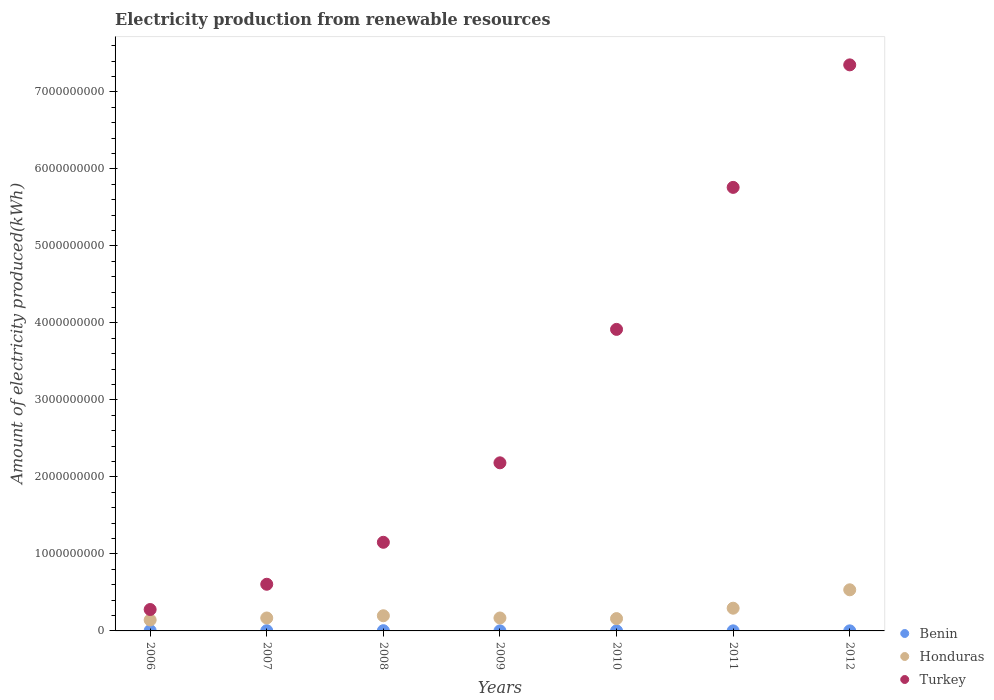How many different coloured dotlines are there?
Ensure brevity in your answer.  3. What is the amount of electricity produced in Benin in 2008?
Make the answer very short. 3.00e+06. Across all years, what is the maximum amount of electricity produced in Turkey?
Offer a very short reply. 7.35e+09. Across all years, what is the minimum amount of electricity produced in Turkey?
Make the answer very short. 2.78e+08. In which year was the amount of electricity produced in Benin minimum?
Provide a succinct answer. 2009. What is the total amount of electricity produced in Turkey in the graph?
Your answer should be very brief. 2.12e+1. What is the difference between the amount of electricity produced in Honduras in 2008 and that in 2010?
Your response must be concise. 3.70e+07. What is the difference between the amount of electricity produced in Honduras in 2010 and the amount of electricity produced in Benin in 2012?
Keep it short and to the point. 1.59e+08. What is the average amount of electricity produced in Honduras per year?
Give a very brief answer. 2.38e+08. In the year 2007, what is the difference between the amount of electricity produced in Turkey and amount of electricity produced in Honduras?
Offer a terse response. 4.38e+08. What is the ratio of the amount of electricity produced in Turkey in 2008 to that in 2010?
Offer a terse response. 0.29. What is the difference between the highest and the second highest amount of electricity produced in Honduras?
Your answer should be very brief. 2.39e+08. Is the sum of the amount of electricity produced in Turkey in 2007 and 2012 greater than the maximum amount of electricity produced in Honduras across all years?
Your answer should be compact. Yes. Does the amount of electricity produced in Turkey monotonically increase over the years?
Your answer should be compact. Yes. Is the amount of electricity produced in Turkey strictly less than the amount of electricity produced in Benin over the years?
Give a very brief answer. No. How many dotlines are there?
Keep it short and to the point. 3. What is the difference between two consecutive major ticks on the Y-axis?
Your answer should be very brief. 1.00e+09. Are the values on the major ticks of Y-axis written in scientific E-notation?
Your response must be concise. No. Does the graph contain any zero values?
Provide a short and direct response. No. Where does the legend appear in the graph?
Your answer should be compact. Bottom right. How are the legend labels stacked?
Keep it short and to the point. Vertical. What is the title of the graph?
Give a very brief answer. Electricity production from renewable resources. What is the label or title of the Y-axis?
Your answer should be compact. Amount of electricity produced(kWh). What is the Amount of electricity produced(kWh) of Honduras in 2006?
Your answer should be compact. 1.42e+08. What is the Amount of electricity produced(kWh) in Turkey in 2006?
Provide a short and direct response. 2.78e+08. What is the Amount of electricity produced(kWh) of Benin in 2007?
Give a very brief answer. 3.00e+06. What is the Amount of electricity produced(kWh) in Honduras in 2007?
Your answer should be compact. 1.68e+08. What is the Amount of electricity produced(kWh) in Turkey in 2007?
Ensure brevity in your answer.  6.06e+08. What is the Amount of electricity produced(kWh) of Honduras in 2008?
Offer a terse response. 1.97e+08. What is the Amount of electricity produced(kWh) of Turkey in 2008?
Provide a short and direct response. 1.15e+09. What is the Amount of electricity produced(kWh) in Honduras in 2009?
Ensure brevity in your answer.  1.68e+08. What is the Amount of electricity produced(kWh) in Turkey in 2009?
Keep it short and to the point. 2.18e+09. What is the Amount of electricity produced(kWh) in Benin in 2010?
Give a very brief answer. 1.00e+06. What is the Amount of electricity produced(kWh) of Honduras in 2010?
Your response must be concise. 1.60e+08. What is the Amount of electricity produced(kWh) in Turkey in 2010?
Provide a succinct answer. 3.92e+09. What is the Amount of electricity produced(kWh) in Honduras in 2011?
Offer a very short reply. 2.95e+08. What is the Amount of electricity produced(kWh) of Turkey in 2011?
Offer a very short reply. 5.76e+09. What is the Amount of electricity produced(kWh) in Honduras in 2012?
Provide a succinct answer. 5.34e+08. What is the Amount of electricity produced(kWh) in Turkey in 2012?
Your answer should be compact. 7.35e+09. Across all years, what is the maximum Amount of electricity produced(kWh) of Benin?
Offer a terse response. 4.00e+06. Across all years, what is the maximum Amount of electricity produced(kWh) of Honduras?
Ensure brevity in your answer.  5.34e+08. Across all years, what is the maximum Amount of electricity produced(kWh) in Turkey?
Give a very brief answer. 7.35e+09. Across all years, what is the minimum Amount of electricity produced(kWh) in Benin?
Make the answer very short. 1.00e+06. Across all years, what is the minimum Amount of electricity produced(kWh) in Honduras?
Provide a succinct answer. 1.42e+08. Across all years, what is the minimum Amount of electricity produced(kWh) of Turkey?
Ensure brevity in your answer.  2.78e+08. What is the total Amount of electricity produced(kWh) of Benin in the graph?
Your answer should be very brief. 1.40e+07. What is the total Amount of electricity produced(kWh) of Honduras in the graph?
Give a very brief answer. 1.66e+09. What is the total Amount of electricity produced(kWh) in Turkey in the graph?
Your answer should be compact. 2.12e+1. What is the difference between the Amount of electricity produced(kWh) in Benin in 2006 and that in 2007?
Make the answer very short. 1.00e+06. What is the difference between the Amount of electricity produced(kWh) in Honduras in 2006 and that in 2007?
Offer a very short reply. -2.60e+07. What is the difference between the Amount of electricity produced(kWh) of Turkey in 2006 and that in 2007?
Your response must be concise. -3.28e+08. What is the difference between the Amount of electricity produced(kWh) in Benin in 2006 and that in 2008?
Make the answer very short. 1.00e+06. What is the difference between the Amount of electricity produced(kWh) of Honduras in 2006 and that in 2008?
Offer a terse response. -5.50e+07. What is the difference between the Amount of electricity produced(kWh) of Turkey in 2006 and that in 2008?
Your answer should be very brief. -8.73e+08. What is the difference between the Amount of electricity produced(kWh) of Benin in 2006 and that in 2009?
Ensure brevity in your answer.  3.00e+06. What is the difference between the Amount of electricity produced(kWh) of Honduras in 2006 and that in 2009?
Offer a terse response. -2.60e+07. What is the difference between the Amount of electricity produced(kWh) of Turkey in 2006 and that in 2009?
Your answer should be very brief. -1.90e+09. What is the difference between the Amount of electricity produced(kWh) in Honduras in 2006 and that in 2010?
Your answer should be very brief. -1.80e+07. What is the difference between the Amount of electricity produced(kWh) in Turkey in 2006 and that in 2010?
Your answer should be compact. -3.64e+09. What is the difference between the Amount of electricity produced(kWh) in Benin in 2006 and that in 2011?
Provide a short and direct response. 3.00e+06. What is the difference between the Amount of electricity produced(kWh) in Honduras in 2006 and that in 2011?
Offer a terse response. -1.53e+08. What is the difference between the Amount of electricity produced(kWh) in Turkey in 2006 and that in 2011?
Offer a terse response. -5.48e+09. What is the difference between the Amount of electricity produced(kWh) in Honduras in 2006 and that in 2012?
Your answer should be compact. -3.92e+08. What is the difference between the Amount of electricity produced(kWh) in Turkey in 2006 and that in 2012?
Provide a succinct answer. -7.07e+09. What is the difference between the Amount of electricity produced(kWh) of Benin in 2007 and that in 2008?
Provide a short and direct response. 0. What is the difference between the Amount of electricity produced(kWh) of Honduras in 2007 and that in 2008?
Offer a terse response. -2.90e+07. What is the difference between the Amount of electricity produced(kWh) in Turkey in 2007 and that in 2008?
Keep it short and to the point. -5.45e+08. What is the difference between the Amount of electricity produced(kWh) of Honduras in 2007 and that in 2009?
Offer a very short reply. 0. What is the difference between the Amount of electricity produced(kWh) of Turkey in 2007 and that in 2009?
Provide a short and direct response. -1.58e+09. What is the difference between the Amount of electricity produced(kWh) in Benin in 2007 and that in 2010?
Make the answer very short. 2.00e+06. What is the difference between the Amount of electricity produced(kWh) in Turkey in 2007 and that in 2010?
Offer a very short reply. -3.31e+09. What is the difference between the Amount of electricity produced(kWh) of Honduras in 2007 and that in 2011?
Offer a very short reply. -1.27e+08. What is the difference between the Amount of electricity produced(kWh) of Turkey in 2007 and that in 2011?
Keep it short and to the point. -5.15e+09. What is the difference between the Amount of electricity produced(kWh) of Honduras in 2007 and that in 2012?
Your answer should be compact. -3.66e+08. What is the difference between the Amount of electricity produced(kWh) in Turkey in 2007 and that in 2012?
Offer a terse response. -6.74e+09. What is the difference between the Amount of electricity produced(kWh) of Honduras in 2008 and that in 2009?
Keep it short and to the point. 2.90e+07. What is the difference between the Amount of electricity produced(kWh) in Turkey in 2008 and that in 2009?
Offer a very short reply. -1.03e+09. What is the difference between the Amount of electricity produced(kWh) in Honduras in 2008 and that in 2010?
Keep it short and to the point. 3.70e+07. What is the difference between the Amount of electricity produced(kWh) in Turkey in 2008 and that in 2010?
Your answer should be compact. -2.76e+09. What is the difference between the Amount of electricity produced(kWh) of Benin in 2008 and that in 2011?
Keep it short and to the point. 2.00e+06. What is the difference between the Amount of electricity produced(kWh) in Honduras in 2008 and that in 2011?
Your response must be concise. -9.80e+07. What is the difference between the Amount of electricity produced(kWh) in Turkey in 2008 and that in 2011?
Your answer should be very brief. -4.61e+09. What is the difference between the Amount of electricity produced(kWh) in Honduras in 2008 and that in 2012?
Ensure brevity in your answer.  -3.37e+08. What is the difference between the Amount of electricity produced(kWh) in Turkey in 2008 and that in 2012?
Offer a very short reply. -6.20e+09. What is the difference between the Amount of electricity produced(kWh) of Turkey in 2009 and that in 2010?
Provide a short and direct response. -1.73e+09. What is the difference between the Amount of electricity produced(kWh) of Honduras in 2009 and that in 2011?
Offer a terse response. -1.27e+08. What is the difference between the Amount of electricity produced(kWh) of Turkey in 2009 and that in 2011?
Ensure brevity in your answer.  -3.58e+09. What is the difference between the Amount of electricity produced(kWh) in Honduras in 2009 and that in 2012?
Your answer should be very brief. -3.66e+08. What is the difference between the Amount of electricity produced(kWh) of Turkey in 2009 and that in 2012?
Offer a very short reply. -5.17e+09. What is the difference between the Amount of electricity produced(kWh) in Honduras in 2010 and that in 2011?
Your answer should be compact. -1.35e+08. What is the difference between the Amount of electricity produced(kWh) in Turkey in 2010 and that in 2011?
Your answer should be compact. -1.84e+09. What is the difference between the Amount of electricity produced(kWh) in Benin in 2010 and that in 2012?
Offer a terse response. 0. What is the difference between the Amount of electricity produced(kWh) in Honduras in 2010 and that in 2012?
Your answer should be very brief. -3.74e+08. What is the difference between the Amount of electricity produced(kWh) in Turkey in 2010 and that in 2012?
Your answer should be very brief. -3.44e+09. What is the difference between the Amount of electricity produced(kWh) in Benin in 2011 and that in 2012?
Give a very brief answer. 0. What is the difference between the Amount of electricity produced(kWh) in Honduras in 2011 and that in 2012?
Your answer should be compact. -2.39e+08. What is the difference between the Amount of electricity produced(kWh) of Turkey in 2011 and that in 2012?
Offer a very short reply. -1.59e+09. What is the difference between the Amount of electricity produced(kWh) of Benin in 2006 and the Amount of electricity produced(kWh) of Honduras in 2007?
Keep it short and to the point. -1.64e+08. What is the difference between the Amount of electricity produced(kWh) in Benin in 2006 and the Amount of electricity produced(kWh) in Turkey in 2007?
Your answer should be compact. -6.02e+08. What is the difference between the Amount of electricity produced(kWh) of Honduras in 2006 and the Amount of electricity produced(kWh) of Turkey in 2007?
Make the answer very short. -4.64e+08. What is the difference between the Amount of electricity produced(kWh) in Benin in 2006 and the Amount of electricity produced(kWh) in Honduras in 2008?
Make the answer very short. -1.93e+08. What is the difference between the Amount of electricity produced(kWh) in Benin in 2006 and the Amount of electricity produced(kWh) in Turkey in 2008?
Offer a terse response. -1.15e+09. What is the difference between the Amount of electricity produced(kWh) of Honduras in 2006 and the Amount of electricity produced(kWh) of Turkey in 2008?
Your answer should be very brief. -1.01e+09. What is the difference between the Amount of electricity produced(kWh) of Benin in 2006 and the Amount of electricity produced(kWh) of Honduras in 2009?
Your answer should be compact. -1.64e+08. What is the difference between the Amount of electricity produced(kWh) of Benin in 2006 and the Amount of electricity produced(kWh) of Turkey in 2009?
Give a very brief answer. -2.18e+09. What is the difference between the Amount of electricity produced(kWh) of Honduras in 2006 and the Amount of electricity produced(kWh) of Turkey in 2009?
Give a very brief answer. -2.04e+09. What is the difference between the Amount of electricity produced(kWh) of Benin in 2006 and the Amount of electricity produced(kWh) of Honduras in 2010?
Provide a succinct answer. -1.56e+08. What is the difference between the Amount of electricity produced(kWh) of Benin in 2006 and the Amount of electricity produced(kWh) of Turkey in 2010?
Make the answer very short. -3.91e+09. What is the difference between the Amount of electricity produced(kWh) of Honduras in 2006 and the Amount of electricity produced(kWh) of Turkey in 2010?
Provide a short and direct response. -3.77e+09. What is the difference between the Amount of electricity produced(kWh) in Benin in 2006 and the Amount of electricity produced(kWh) in Honduras in 2011?
Your response must be concise. -2.91e+08. What is the difference between the Amount of electricity produced(kWh) in Benin in 2006 and the Amount of electricity produced(kWh) in Turkey in 2011?
Your answer should be very brief. -5.76e+09. What is the difference between the Amount of electricity produced(kWh) of Honduras in 2006 and the Amount of electricity produced(kWh) of Turkey in 2011?
Your answer should be compact. -5.62e+09. What is the difference between the Amount of electricity produced(kWh) of Benin in 2006 and the Amount of electricity produced(kWh) of Honduras in 2012?
Give a very brief answer. -5.30e+08. What is the difference between the Amount of electricity produced(kWh) of Benin in 2006 and the Amount of electricity produced(kWh) of Turkey in 2012?
Offer a very short reply. -7.35e+09. What is the difference between the Amount of electricity produced(kWh) of Honduras in 2006 and the Amount of electricity produced(kWh) of Turkey in 2012?
Provide a succinct answer. -7.21e+09. What is the difference between the Amount of electricity produced(kWh) in Benin in 2007 and the Amount of electricity produced(kWh) in Honduras in 2008?
Provide a short and direct response. -1.94e+08. What is the difference between the Amount of electricity produced(kWh) of Benin in 2007 and the Amount of electricity produced(kWh) of Turkey in 2008?
Offer a very short reply. -1.15e+09. What is the difference between the Amount of electricity produced(kWh) of Honduras in 2007 and the Amount of electricity produced(kWh) of Turkey in 2008?
Your response must be concise. -9.83e+08. What is the difference between the Amount of electricity produced(kWh) of Benin in 2007 and the Amount of electricity produced(kWh) of Honduras in 2009?
Make the answer very short. -1.65e+08. What is the difference between the Amount of electricity produced(kWh) in Benin in 2007 and the Amount of electricity produced(kWh) in Turkey in 2009?
Give a very brief answer. -2.18e+09. What is the difference between the Amount of electricity produced(kWh) of Honduras in 2007 and the Amount of electricity produced(kWh) of Turkey in 2009?
Your answer should be compact. -2.02e+09. What is the difference between the Amount of electricity produced(kWh) of Benin in 2007 and the Amount of electricity produced(kWh) of Honduras in 2010?
Give a very brief answer. -1.57e+08. What is the difference between the Amount of electricity produced(kWh) in Benin in 2007 and the Amount of electricity produced(kWh) in Turkey in 2010?
Keep it short and to the point. -3.91e+09. What is the difference between the Amount of electricity produced(kWh) in Honduras in 2007 and the Amount of electricity produced(kWh) in Turkey in 2010?
Your answer should be very brief. -3.75e+09. What is the difference between the Amount of electricity produced(kWh) of Benin in 2007 and the Amount of electricity produced(kWh) of Honduras in 2011?
Ensure brevity in your answer.  -2.92e+08. What is the difference between the Amount of electricity produced(kWh) in Benin in 2007 and the Amount of electricity produced(kWh) in Turkey in 2011?
Provide a succinct answer. -5.76e+09. What is the difference between the Amount of electricity produced(kWh) of Honduras in 2007 and the Amount of electricity produced(kWh) of Turkey in 2011?
Offer a very short reply. -5.59e+09. What is the difference between the Amount of electricity produced(kWh) in Benin in 2007 and the Amount of electricity produced(kWh) in Honduras in 2012?
Offer a terse response. -5.31e+08. What is the difference between the Amount of electricity produced(kWh) of Benin in 2007 and the Amount of electricity produced(kWh) of Turkey in 2012?
Give a very brief answer. -7.35e+09. What is the difference between the Amount of electricity produced(kWh) in Honduras in 2007 and the Amount of electricity produced(kWh) in Turkey in 2012?
Give a very brief answer. -7.18e+09. What is the difference between the Amount of electricity produced(kWh) of Benin in 2008 and the Amount of electricity produced(kWh) of Honduras in 2009?
Your answer should be compact. -1.65e+08. What is the difference between the Amount of electricity produced(kWh) in Benin in 2008 and the Amount of electricity produced(kWh) in Turkey in 2009?
Keep it short and to the point. -2.18e+09. What is the difference between the Amount of electricity produced(kWh) of Honduras in 2008 and the Amount of electricity produced(kWh) of Turkey in 2009?
Ensure brevity in your answer.  -1.99e+09. What is the difference between the Amount of electricity produced(kWh) in Benin in 2008 and the Amount of electricity produced(kWh) in Honduras in 2010?
Give a very brief answer. -1.57e+08. What is the difference between the Amount of electricity produced(kWh) of Benin in 2008 and the Amount of electricity produced(kWh) of Turkey in 2010?
Provide a short and direct response. -3.91e+09. What is the difference between the Amount of electricity produced(kWh) in Honduras in 2008 and the Amount of electricity produced(kWh) in Turkey in 2010?
Give a very brief answer. -3.72e+09. What is the difference between the Amount of electricity produced(kWh) of Benin in 2008 and the Amount of electricity produced(kWh) of Honduras in 2011?
Make the answer very short. -2.92e+08. What is the difference between the Amount of electricity produced(kWh) of Benin in 2008 and the Amount of electricity produced(kWh) of Turkey in 2011?
Offer a very short reply. -5.76e+09. What is the difference between the Amount of electricity produced(kWh) of Honduras in 2008 and the Amount of electricity produced(kWh) of Turkey in 2011?
Offer a terse response. -5.56e+09. What is the difference between the Amount of electricity produced(kWh) of Benin in 2008 and the Amount of electricity produced(kWh) of Honduras in 2012?
Offer a very short reply. -5.31e+08. What is the difference between the Amount of electricity produced(kWh) in Benin in 2008 and the Amount of electricity produced(kWh) in Turkey in 2012?
Provide a succinct answer. -7.35e+09. What is the difference between the Amount of electricity produced(kWh) in Honduras in 2008 and the Amount of electricity produced(kWh) in Turkey in 2012?
Provide a succinct answer. -7.15e+09. What is the difference between the Amount of electricity produced(kWh) of Benin in 2009 and the Amount of electricity produced(kWh) of Honduras in 2010?
Provide a short and direct response. -1.59e+08. What is the difference between the Amount of electricity produced(kWh) of Benin in 2009 and the Amount of electricity produced(kWh) of Turkey in 2010?
Make the answer very short. -3.92e+09. What is the difference between the Amount of electricity produced(kWh) in Honduras in 2009 and the Amount of electricity produced(kWh) in Turkey in 2010?
Provide a succinct answer. -3.75e+09. What is the difference between the Amount of electricity produced(kWh) in Benin in 2009 and the Amount of electricity produced(kWh) in Honduras in 2011?
Your answer should be very brief. -2.94e+08. What is the difference between the Amount of electricity produced(kWh) of Benin in 2009 and the Amount of electricity produced(kWh) of Turkey in 2011?
Offer a very short reply. -5.76e+09. What is the difference between the Amount of electricity produced(kWh) of Honduras in 2009 and the Amount of electricity produced(kWh) of Turkey in 2011?
Make the answer very short. -5.59e+09. What is the difference between the Amount of electricity produced(kWh) in Benin in 2009 and the Amount of electricity produced(kWh) in Honduras in 2012?
Ensure brevity in your answer.  -5.33e+08. What is the difference between the Amount of electricity produced(kWh) of Benin in 2009 and the Amount of electricity produced(kWh) of Turkey in 2012?
Make the answer very short. -7.35e+09. What is the difference between the Amount of electricity produced(kWh) in Honduras in 2009 and the Amount of electricity produced(kWh) in Turkey in 2012?
Provide a succinct answer. -7.18e+09. What is the difference between the Amount of electricity produced(kWh) in Benin in 2010 and the Amount of electricity produced(kWh) in Honduras in 2011?
Give a very brief answer. -2.94e+08. What is the difference between the Amount of electricity produced(kWh) of Benin in 2010 and the Amount of electricity produced(kWh) of Turkey in 2011?
Keep it short and to the point. -5.76e+09. What is the difference between the Amount of electricity produced(kWh) in Honduras in 2010 and the Amount of electricity produced(kWh) in Turkey in 2011?
Provide a succinct answer. -5.60e+09. What is the difference between the Amount of electricity produced(kWh) of Benin in 2010 and the Amount of electricity produced(kWh) of Honduras in 2012?
Your answer should be compact. -5.33e+08. What is the difference between the Amount of electricity produced(kWh) in Benin in 2010 and the Amount of electricity produced(kWh) in Turkey in 2012?
Keep it short and to the point. -7.35e+09. What is the difference between the Amount of electricity produced(kWh) of Honduras in 2010 and the Amount of electricity produced(kWh) of Turkey in 2012?
Make the answer very short. -7.19e+09. What is the difference between the Amount of electricity produced(kWh) in Benin in 2011 and the Amount of electricity produced(kWh) in Honduras in 2012?
Keep it short and to the point. -5.33e+08. What is the difference between the Amount of electricity produced(kWh) of Benin in 2011 and the Amount of electricity produced(kWh) of Turkey in 2012?
Keep it short and to the point. -7.35e+09. What is the difference between the Amount of electricity produced(kWh) in Honduras in 2011 and the Amount of electricity produced(kWh) in Turkey in 2012?
Ensure brevity in your answer.  -7.06e+09. What is the average Amount of electricity produced(kWh) in Benin per year?
Your response must be concise. 2.00e+06. What is the average Amount of electricity produced(kWh) of Honduras per year?
Make the answer very short. 2.38e+08. What is the average Amount of electricity produced(kWh) of Turkey per year?
Give a very brief answer. 3.04e+09. In the year 2006, what is the difference between the Amount of electricity produced(kWh) of Benin and Amount of electricity produced(kWh) of Honduras?
Provide a short and direct response. -1.38e+08. In the year 2006, what is the difference between the Amount of electricity produced(kWh) of Benin and Amount of electricity produced(kWh) of Turkey?
Provide a succinct answer. -2.74e+08. In the year 2006, what is the difference between the Amount of electricity produced(kWh) in Honduras and Amount of electricity produced(kWh) in Turkey?
Keep it short and to the point. -1.36e+08. In the year 2007, what is the difference between the Amount of electricity produced(kWh) in Benin and Amount of electricity produced(kWh) in Honduras?
Make the answer very short. -1.65e+08. In the year 2007, what is the difference between the Amount of electricity produced(kWh) of Benin and Amount of electricity produced(kWh) of Turkey?
Your response must be concise. -6.03e+08. In the year 2007, what is the difference between the Amount of electricity produced(kWh) in Honduras and Amount of electricity produced(kWh) in Turkey?
Keep it short and to the point. -4.38e+08. In the year 2008, what is the difference between the Amount of electricity produced(kWh) of Benin and Amount of electricity produced(kWh) of Honduras?
Give a very brief answer. -1.94e+08. In the year 2008, what is the difference between the Amount of electricity produced(kWh) of Benin and Amount of electricity produced(kWh) of Turkey?
Your answer should be compact. -1.15e+09. In the year 2008, what is the difference between the Amount of electricity produced(kWh) in Honduras and Amount of electricity produced(kWh) in Turkey?
Provide a succinct answer. -9.54e+08. In the year 2009, what is the difference between the Amount of electricity produced(kWh) in Benin and Amount of electricity produced(kWh) in Honduras?
Ensure brevity in your answer.  -1.67e+08. In the year 2009, what is the difference between the Amount of electricity produced(kWh) in Benin and Amount of electricity produced(kWh) in Turkey?
Your answer should be compact. -2.18e+09. In the year 2009, what is the difference between the Amount of electricity produced(kWh) of Honduras and Amount of electricity produced(kWh) of Turkey?
Offer a very short reply. -2.02e+09. In the year 2010, what is the difference between the Amount of electricity produced(kWh) of Benin and Amount of electricity produced(kWh) of Honduras?
Your answer should be compact. -1.59e+08. In the year 2010, what is the difference between the Amount of electricity produced(kWh) in Benin and Amount of electricity produced(kWh) in Turkey?
Keep it short and to the point. -3.92e+09. In the year 2010, what is the difference between the Amount of electricity produced(kWh) in Honduras and Amount of electricity produced(kWh) in Turkey?
Your answer should be very brief. -3.76e+09. In the year 2011, what is the difference between the Amount of electricity produced(kWh) of Benin and Amount of electricity produced(kWh) of Honduras?
Your response must be concise. -2.94e+08. In the year 2011, what is the difference between the Amount of electricity produced(kWh) in Benin and Amount of electricity produced(kWh) in Turkey?
Offer a very short reply. -5.76e+09. In the year 2011, what is the difference between the Amount of electricity produced(kWh) in Honduras and Amount of electricity produced(kWh) in Turkey?
Provide a succinct answer. -5.46e+09. In the year 2012, what is the difference between the Amount of electricity produced(kWh) in Benin and Amount of electricity produced(kWh) in Honduras?
Offer a terse response. -5.33e+08. In the year 2012, what is the difference between the Amount of electricity produced(kWh) in Benin and Amount of electricity produced(kWh) in Turkey?
Offer a terse response. -7.35e+09. In the year 2012, what is the difference between the Amount of electricity produced(kWh) of Honduras and Amount of electricity produced(kWh) of Turkey?
Offer a terse response. -6.82e+09. What is the ratio of the Amount of electricity produced(kWh) in Benin in 2006 to that in 2007?
Give a very brief answer. 1.33. What is the ratio of the Amount of electricity produced(kWh) in Honduras in 2006 to that in 2007?
Your response must be concise. 0.85. What is the ratio of the Amount of electricity produced(kWh) in Turkey in 2006 to that in 2007?
Keep it short and to the point. 0.46. What is the ratio of the Amount of electricity produced(kWh) of Benin in 2006 to that in 2008?
Your response must be concise. 1.33. What is the ratio of the Amount of electricity produced(kWh) in Honduras in 2006 to that in 2008?
Provide a short and direct response. 0.72. What is the ratio of the Amount of electricity produced(kWh) in Turkey in 2006 to that in 2008?
Offer a terse response. 0.24. What is the ratio of the Amount of electricity produced(kWh) in Honduras in 2006 to that in 2009?
Offer a very short reply. 0.85. What is the ratio of the Amount of electricity produced(kWh) of Turkey in 2006 to that in 2009?
Give a very brief answer. 0.13. What is the ratio of the Amount of electricity produced(kWh) in Honduras in 2006 to that in 2010?
Offer a terse response. 0.89. What is the ratio of the Amount of electricity produced(kWh) in Turkey in 2006 to that in 2010?
Provide a succinct answer. 0.07. What is the ratio of the Amount of electricity produced(kWh) in Benin in 2006 to that in 2011?
Provide a short and direct response. 4. What is the ratio of the Amount of electricity produced(kWh) in Honduras in 2006 to that in 2011?
Your response must be concise. 0.48. What is the ratio of the Amount of electricity produced(kWh) of Turkey in 2006 to that in 2011?
Provide a short and direct response. 0.05. What is the ratio of the Amount of electricity produced(kWh) in Benin in 2006 to that in 2012?
Offer a terse response. 4. What is the ratio of the Amount of electricity produced(kWh) of Honduras in 2006 to that in 2012?
Give a very brief answer. 0.27. What is the ratio of the Amount of electricity produced(kWh) of Turkey in 2006 to that in 2012?
Offer a very short reply. 0.04. What is the ratio of the Amount of electricity produced(kWh) of Benin in 2007 to that in 2008?
Make the answer very short. 1. What is the ratio of the Amount of electricity produced(kWh) of Honduras in 2007 to that in 2008?
Your response must be concise. 0.85. What is the ratio of the Amount of electricity produced(kWh) of Turkey in 2007 to that in 2008?
Your answer should be compact. 0.53. What is the ratio of the Amount of electricity produced(kWh) in Turkey in 2007 to that in 2009?
Your response must be concise. 0.28. What is the ratio of the Amount of electricity produced(kWh) of Honduras in 2007 to that in 2010?
Provide a short and direct response. 1.05. What is the ratio of the Amount of electricity produced(kWh) in Turkey in 2007 to that in 2010?
Provide a short and direct response. 0.15. What is the ratio of the Amount of electricity produced(kWh) of Benin in 2007 to that in 2011?
Provide a succinct answer. 3. What is the ratio of the Amount of electricity produced(kWh) in Honduras in 2007 to that in 2011?
Make the answer very short. 0.57. What is the ratio of the Amount of electricity produced(kWh) of Turkey in 2007 to that in 2011?
Give a very brief answer. 0.11. What is the ratio of the Amount of electricity produced(kWh) in Benin in 2007 to that in 2012?
Provide a short and direct response. 3. What is the ratio of the Amount of electricity produced(kWh) in Honduras in 2007 to that in 2012?
Provide a short and direct response. 0.31. What is the ratio of the Amount of electricity produced(kWh) of Turkey in 2007 to that in 2012?
Your answer should be compact. 0.08. What is the ratio of the Amount of electricity produced(kWh) of Honduras in 2008 to that in 2009?
Keep it short and to the point. 1.17. What is the ratio of the Amount of electricity produced(kWh) in Turkey in 2008 to that in 2009?
Give a very brief answer. 0.53. What is the ratio of the Amount of electricity produced(kWh) in Benin in 2008 to that in 2010?
Keep it short and to the point. 3. What is the ratio of the Amount of electricity produced(kWh) in Honduras in 2008 to that in 2010?
Offer a terse response. 1.23. What is the ratio of the Amount of electricity produced(kWh) of Turkey in 2008 to that in 2010?
Give a very brief answer. 0.29. What is the ratio of the Amount of electricity produced(kWh) of Honduras in 2008 to that in 2011?
Ensure brevity in your answer.  0.67. What is the ratio of the Amount of electricity produced(kWh) in Turkey in 2008 to that in 2011?
Keep it short and to the point. 0.2. What is the ratio of the Amount of electricity produced(kWh) in Benin in 2008 to that in 2012?
Your answer should be compact. 3. What is the ratio of the Amount of electricity produced(kWh) in Honduras in 2008 to that in 2012?
Your answer should be very brief. 0.37. What is the ratio of the Amount of electricity produced(kWh) in Turkey in 2008 to that in 2012?
Your answer should be very brief. 0.16. What is the ratio of the Amount of electricity produced(kWh) of Benin in 2009 to that in 2010?
Offer a very short reply. 1. What is the ratio of the Amount of electricity produced(kWh) of Turkey in 2009 to that in 2010?
Give a very brief answer. 0.56. What is the ratio of the Amount of electricity produced(kWh) in Benin in 2009 to that in 2011?
Keep it short and to the point. 1. What is the ratio of the Amount of electricity produced(kWh) in Honduras in 2009 to that in 2011?
Keep it short and to the point. 0.57. What is the ratio of the Amount of electricity produced(kWh) in Turkey in 2009 to that in 2011?
Offer a very short reply. 0.38. What is the ratio of the Amount of electricity produced(kWh) in Honduras in 2009 to that in 2012?
Your answer should be very brief. 0.31. What is the ratio of the Amount of electricity produced(kWh) in Turkey in 2009 to that in 2012?
Keep it short and to the point. 0.3. What is the ratio of the Amount of electricity produced(kWh) in Honduras in 2010 to that in 2011?
Your answer should be compact. 0.54. What is the ratio of the Amount of electricity produced(kWh) of Turkey in 2010 to that in 2011?
Give a very brief answer. 0.68. What is the ratio of the Amount of electricity produced(kWh) of Benin in 2010 to that in 2012?
Provide a succinct answer. 1. What is the ratio of the Amount of electricity produced(kWh) of Honduras in 2010 to that in 2012?
Your answer should be compact. 0.3. What is the ratio of the Amount of electricity produced(kWh) of Turkey in 2010 to that in 2012?
Offer a very short reply. 0.53. What is the ratio of the Amount of electricity produced(kWh) of Benin in 2011 to that in 2012?
Your answer should be compact. 1. What is the ratio of the Amount of electricity produced(kWh) of Honduras in 2011 to that in 2012?
Offer a terse response. 0.55. What is the ratio of the Amount of electricity produced(kWh) of Turkey in 2011 to that in 2012?
Keep it short and to the point. 0.78. What is the difference between the highest and the second highest Amount of electricity produced(kWh) in Honduras?
Your answer should be compact. 2.39e+08. What is the difference between the highest and the second highest Amount of electricity produced(kWh) of Turkey?
Offer a terse response. 1.59e+09. What is the difference between the highest and the lowest Amount of electricity produced(kWh) in Honduras?
Provide a succinct answer. 3.92e+08. What is the difference between the highest and the lowest Amount of electricity produced(kWh) of Turkey?
Keep it short and to the point. 7.07e+09. 